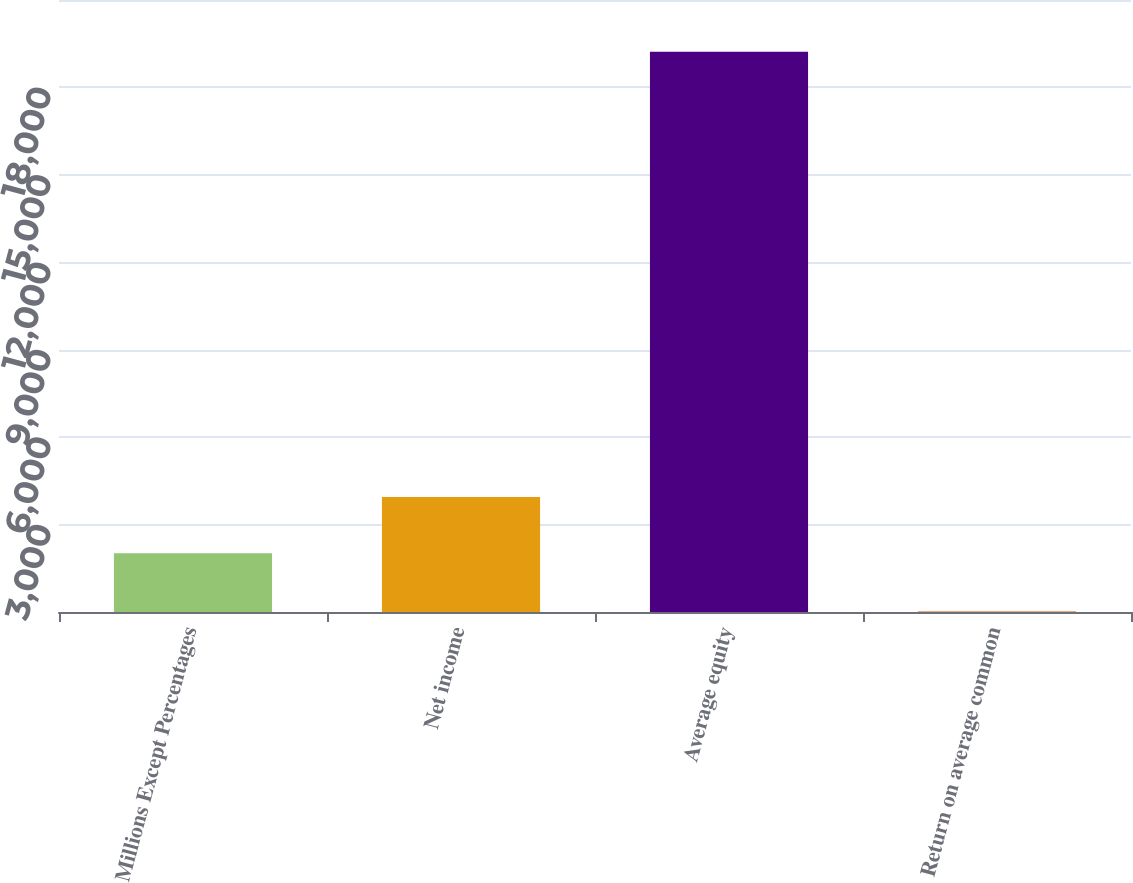Convert chart to OTSL. <chart><loc_0><loc_0><loc_500><loc_500><bar_chart><fcel>Millions Except Percentages<fcel>Net income<fcel>Average equity<fcel>Return on average common<nl><fcel>2012<fcel>3943<fcel>19228<fcel>20.5<nl></chart> 